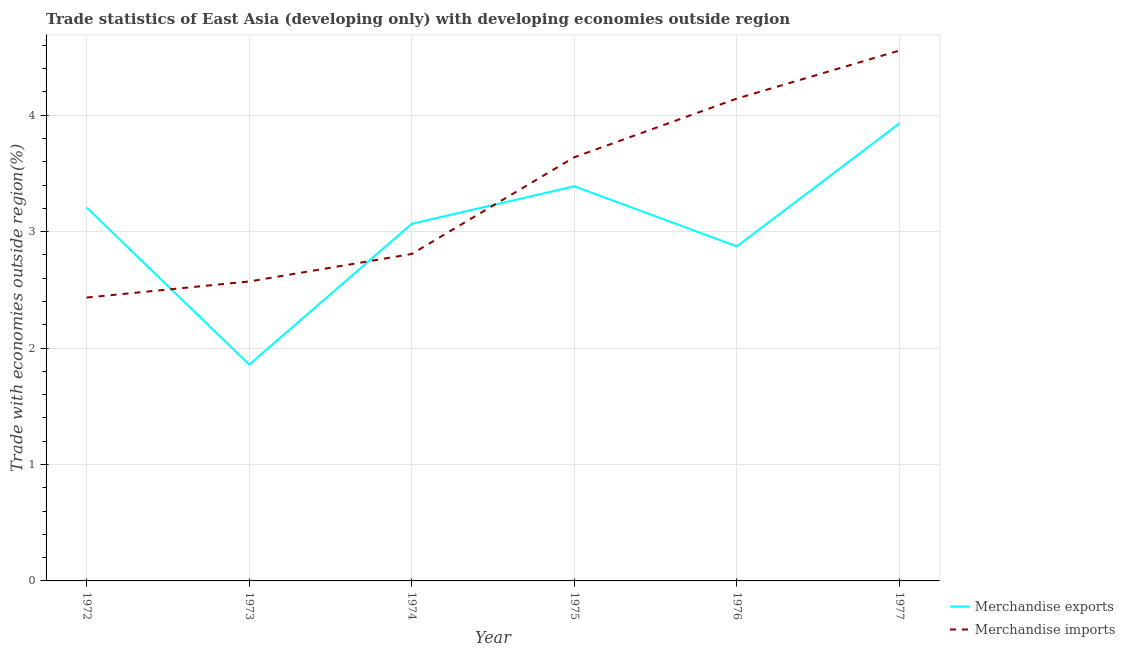How many different coloured lines are there?
Keep it short and to the point. 2. Is the number of lines equal to the number of legend labels?
Your answer should be compact. Yes. What is the merchandise exports in 1976?
Offer a very short reply. 2.87. Across all years, what is the maximum merchandise imports?
Make the answer very short. 4.56. Across all years, what is the minimum merchandise exports?
Your answer should be compact. 1.86. In which year was the merchandise imports maximum?
Offer a terse response. 1977. In which year was the merchandise exports minimum?
Make the answer very short. 1973. What is the total merchandise imports in the graph?
Provide a short and direct response. 20.15. What is the difference between the merchandise imports in 1972 and that in 1977?
Your answer should be very brief. -2.12. What is the difference between the merchandise exports in 1973 and the merchandise imports in 1977?
Your answer should be very brief. -2.7. What is the average merchandise imports per year?
Your answer should be compact. 3.36. In the year 1976, what is the difference between the merchandise imports and merchandise exports?
Make the answer very short. 1.27. In how many years, is the merchandise imports greater than 3.2 %?
Make the answer very short. 3. What is the ratio of the merchandise exports in 1973 to that in 1976?
Make the answer very short. 0.65. Is the merchandise exports in 1973 less than that in 1976?
Provide a short and direct response. Yes. What is the difference between the highest and the second highest merchandise exports?
Provide a short and direct response. 0.54. What is the difference between the highest and the lowest merchandise exports?
Make the answer very short. 2.07. Does the merchandise exports monotonically increase over the years?
Offer a very short reply. No. What is the difference between two consecutive major ticks on the Y-axis?
Keep it short and to the point. 1. Are the values on the major ticks of Y-axis written in scientific E-notation?
Offer a very short reply. No. Does the graph contain any zero values?
Provide a succinct answer. No. Does the graph contain grids?
Ensure brevity in your answer.  Yes. Where does the legend appear in the graph?
Your answer should be compact. Bottom right. What is the title of the graph?
Offer a very short reply. Trade statistics of East Asia (developing only) with developing economies outside region. Does "Net savings(excluding particulate emission damage)" appear as one of the legend labels in the graph?
Offer a very short reply. No. What is the label or title of the Y-axis?
Ensure brevity in your answer.  Trade with economies outside region(%). What is the Trade with economies outside region(%) in Merchandise exports in 1972?
Ensure brevity in your answer.  3.21. What is the Trade with economies outside region(%) in Merchandise imports in 1972?
Provide a succinct answer. 2.43. What is the Trade with economies outside region(%) of Merchandise exports in 1973?
Provide a short and direct response. 1.86. What is the Trade with economies outside region(%) in Merchandise imports in 1973?
Offer a very short reply. 2.57. What is the Trade with economies outside region(%) of Merchandise exports in 1974?
Make the answer very short. 3.07. What is the Trade with economies outside region(%) of Merchandise imports in 1974?
Provide a succinct answer. 2.81. What is the Trade with economies outside region(%) in Merchandise exports in 1975?
Your response must be concise. 3.39. What is the Trade with economies outside region(%) of Merchandise imports in 1975?
Offer a very short reply. 3.64. What is the Trade with economies outside region(%) of Merchandise exports in 1976?
Offer a terse response. 2.87. What is the Trade with economies outside region(%) of Merchandise imports in 1976?
Your answer should be very brief. 4.14. What is the Trade with economies outside region(%) in Merchandise exports in 1977?
Offer a terse response. 3.93. What is the Trade with economies outside region(%) in Merchandise imports in 1977?
Your answer should be compact. 4.56. Across all years, what is the maximum Trade with economies outside region(%) of Merchandise exports?
Your response must be concise. 3.93. Across all years, what is the maximum Trade with economies outside region(%) in Merchandise imports?
Offer a terse response. 4.56. Across all years, what is the minimum Trade with economies outside region(%) of Merchandise exports?
Offer a terse response. 1.86. Across all years, what is the minimum Trade with economies outside region(%) of Merchandise imports?
Your response must be concise. 2.43. What is the total Trade with economies outside region(%) in Merchandise exports in the graph?
Provide a short and direct response. 18.33. What is the total Trade with economies outside region(%) in Merchandise imports in the graph?
Offer a very short reply. 20.15. What is the difference between the Trade with economies outside region(%) in Merchandise exports in 1972 and that in 1973?
Provide a succinct answer. 1.35. What is the difference between the Trade with economies outside region(%) in Merchandise imports in 1972 and that in 1973?
Provide a short and direct response. -0.14. What is the difference between the Trade with economies outside region(%) of Merchandise exports in 1972 and that in 1974?
Your answer should be very brief. 0.14. What is the difference between the Trade with economies outside region(%) of Merchandise imports in 1972 and that in 1974?
Ensure brevity in your answer.  -0.37. What is the difference between the Trade with economies outside region(%) in Merchandise exports in 1972 and that in 1975?
Offer a terse response. -0.18. What is the difference between the Trade with economies outside region(%) in Merchandise imports in 1972 and that in 1975?
Make the answer very short. -1.21. What is the difference between the Trade with economies outside region(%) in Merchandise exports in 1972 and that in 1976?
Provide a short and direct response. 0.33. What is the difference between the Trade with economies outside region(%) in Merchandise imports in 1972 and that in 1976?
Your answer should be very brief. -1.71. What is the difference between the Trade with economies outside region(%) of Merchandise exports in 1972 and that in 1977?
Your answer should be very brief. -0.72. What is the difference between the Trade with economies outside region(%) in Merchandise imports in 1972 and that in 1977?
Your answer should be very brief. -2.12. What is the difference between the Trade with economies outside region(%) of Merchandise exports in 1973 and that in 1974?
Make the answer very short. -1.21. What is the difference between the Trade with economies outside region(%) in Merchandise imports in 1973 and that in 1974?
Give a very brief answer. -0.24. What is the difference between the Trade with economies outside region(%) of Merchandise exports in 1973 and that in 1975?
Your answer should be compact. -1.53. What is the difference between the Trade with economies outside region(%) of Merchandise imports in 1973 and that in 1975?
Offer a terse response. -1.07. What is the difference between the Trade with economies outside region(%) in Merchandise exports in 1973 and that in 1976?
Give a very brief answer. -1.02. What is the difference between the Trade with economies outside region(%) of Merchandise imports in 1973 and that in 1976?
Your answer should be very brief. -1.57. What is the difference between the Trade with economies outside region(%) of Merchandise exports in 1973 and that in 1977?
Provide a succinct answer. -2.07. What is the difference between the Trade with economies outside region(%) in Merchandise imports in 1973 and that in 1977?
Ensure brevity in your answer.  -1.98. What is the difference between the Trade with economies outside region(%) of Merchandise exports in 1974 and that in 1975?
Keep it short and to the point. -0.32. What is the difference between the Trade with economies outside region(%) in Merchandise imports in 1974 and that in 1975?
Give a very brief answer. -0.83. What is the difference between the Trade with economies outside region(%) in Merchandise exports in 1974 and that in 1976?
Provide a short and direct response. 0.19. What is the difference between the Trade with economies outside region(%) in Merchandise imports in 1974 and that in 1976?
Provide a short and direct response. -1.33. What is the difference between the Trade with economies outside region(%) in Merchandise exports in 1974 and that in 1977?
Offer a terse response. -0.86. What is the difference between the Trade with economies outside region(%) in Merchandise imports in 1974 and that in 1977?
Ensure brevity in your answer.  -1.75. What is the difference between the Trade with economies outside region(%) of Merchandise exports in 1975 and that in 1976?
Ensure brevity in your answer.  0.52. What is the difference between the Trade with economies outside region(%) in Merchandise imports in 1975 and that in 1976?
Provide a short and direct response. -0.5. What is the difference between the Trade with economies outside region(%) in Merchandise exports in 1975 and that in 1977?
Offer a very short reply. -0.54. What is the difference between the Trade with economies outside region(%) in Merchandise imports in 1975 and that in 1977?
Give a very brief answer. -0.92. What is the difference between the Trade with economies outside region(%) in Merchandise exports in 1976 and that in 1977?
Make the answer very short. -1.06. What is the difference between the Trade with economies outside region(%) in Merchandise imports in 1976 and that in 1977?
Ensure brevity in your answer.  -0.41. What is the difference between the Trade with economies outside region(%) in Merchandise exports in 1972 and the Trade with economies outside region(%) in Merchandise imports in 1973?
Give a very brief answer. 0.63. What is the difference between the Trade with economies outside region(%) in Merchandise exports in 1972 and the Trade with economies outside region(%) in Merchandise imports in 1974?
Your answer should be very brief. 0.4. What is the difference between the Trade with economies outside region(%) in Merchandise exports in 1972 and the Trade with economies outside region(%) in Merchandise imports in 1975?
Ensure brevity in your answer.  -0.43. What is the difference between the Trade with economies outside region(%) in Merchandise exports in 1972 and the Trade with economies outside region(%) in Merchandise imports in 1976?
Provide a short and direct response. -0.94. What is the difference between the Trade with economies outside region(%) in Merchandise exports in 1972 and the Trade with economies outside region(%) in Merchandise imports in 1977?
Provide a succinct answer. -1.35. What is the difference between the Trade with economies outside region(%) in Merchandise exports in 1973 and the Trade with economies outside region(%) in Merchandise imports in 1974?
Your answer should be compact. -0.95. What is the difference between the Trade with economies outside region(%) in Merchandise exports in 1973 and the Trade with economies outside region(%) in Merchandise imports in 1975?
Your answer should be compact. -1.78. What is the difference between the Trade with economies outside region(%) of Merchandise exports in 1973 and the Trade with economies outside region(%) of Merchandise imports in 1976?
Your answer should be compact. -2.29. What is the difference between the Trade with economies outside region(%) of Merchandise exports in 1973 and the Trade with economies outside region(%) of Merchandise imports in 1977?
Offer a very short reply. -2.7. What is the difference between the Trade with economies outside region(%) in Merchandise exports in 1974 and the Trade with economies outside region(%) in Merchandise imports in 1975?
Keep it short and to the point. -0.57. What is the difference between the Trade with economies outside region(%) in Merchandise exports in 1974 and the Trade with economies outside region(%) in Merchandise imports in 1976?
Ensure brevity in your answer.  -1.08. What is the difference between the Trade with economies outside region(%) in Merchandise exports in 1974 and the Trade with economies outside region(%) in Merchandise imports in 1977?
Your response must be concise. -1.49. What is the difference between the Trade with economies outside region(%) in Merchandise exports in 1975 and the Trade with economies outside region(%) in Merchandise imports in 1976?
Offer a very short reply. -0.75. What is the difference between the Trade with economies outside region(%) of Merchandise exports in 1975 and the Trade with economies outside region(%) of Merchandise imports in 1977?
Your answer should be very brief. -1.17. What is the difference between the Trade with economies outside region(%) of Merchandise exports in 1976 and the Trade with economies outside region(%) of Merchandise imports in 1977?
Offer a terse response. -1.68. What is the average Trade with economies outside region(%) of Merchandise exports per year?
Ensure brevity in your answer.  3.05. What is the average Trade with economies outside region(%) in Merchandise imports per year?
Your response must be concise. 3.36. In the year 1972, what is the difference between the Trade with economies outside region(%) of Merchandise exports and Trade with economies outside region(%) of Merchandise imports?
Offer a terse response. 0.77. In the year 1973, what is the difference between the Trade with economies outside region(%) of Merchandise exports and Trade with economies outside region(%) of Merchandise imports?
Provide a succinct answer. -0.71. In the year 1974, what is the difference between the Trade with economies outside region(%) in Merchandise exports and Trade with economies outside region(%) in Merchandise imports?
Your answer should be very brief. 0.26. In the year 1975, what is the difference between the Trade with economies outside region(%) of Merchandise exports and Trade with economies outside region(%) of Merchandise imports?
Give a very brief answer. -0.25. In the year 1976, what is the difference between the Trade with economies outside region(%) in Merchandise exports and Trade with economies outside region(%) in Merchandise imports?
Offer a terse response. -1.27. In the year 1977, what is the difference between the Trade with economies outside region(%) of Merchandise exports and Trade with economies outside region(%) of Merchandise imports?
Ensure brevity in your answer.  -0.63. What is the ratio of the Trade with economies outside region(%) in Merchandise exports in 1972 to that in 1973?
Provide a succinct answer. 1.73. What is the ratio of the Trade with economies outside region(%) of Merchandise imports in 1972 to that in 1973?
Make the answer very short. 0.95. What is the ratio of the Trade with economies outside region(%) in Merchandise exports in 1972 to that in 1974?
Your response must be concise. 1.05. What is the ratio of the Trade with economies outside region(%) of Merchandise imports in 1972 to that in 1974?
Offer a very short reply. 0.87. What is the ratio of the Trade with economies outside region(%) in Merchandise exports in 1972 to that in 1975?
Offer a very short reply. 0.95. What is the ratio of the Trade with economies outside region(%) of Merchandise imports in 1972 to that in 1975?
Provide a succinct answer. 0.67. What is the ratio of the Trade with economies outside region(%) in Merchandise exports in 1972 to that in 1976?
Offer a terse response. 1.12. What is the ratio of the Trade with economies outside region(%) in Merchandise imports in 1972 to that in 1976?
Provide a short and direct response. 0.59. What is the ratio of the Trade with economies outside region(%) of Merchandise exports in 1972 to that in 1977?
Your response must be concise. 0.82. What is the ratio of the Trade with economies outside region(%) in Merchandise imports in 1972 to that in 1977?
Ensure brevity in your answer.  0.53. What is the ratio of the Trade with economies outside region(%) of Merchandise exports in 1973 to that in 1974?
Your answer should be compact. 0.61. What is the ratio of the Trade with economies outside region(%) of Merchandise imports in 1973 to that in 1974?
Provide a short and direct response. 0.92. What is the ratio of the Trade with economies outside region(%) of Merchandise exports in 1973 to that in 1975?
Your answer should be compact. 0.55. What is the ratio of the Trade with economies outside region(%) in Merchandise imports in 1973 to that in 1975?
Your answer should be compact. 0.71. What is the ratio of the Trade with economies outside region(%) in Merchandise exports in 1973 to that in 1976?
Ensure brevity in your answer.  0.65. What is the ratio of the Trade with economies outside region(%) of Merchandise imports in 1973 to that in 1976?
Keep it short and to the point. 0.62. What is the ratio of the Trade with economies outside region(%) of Merchandise exports in 1973 to that in 1977?
Ensure brevity in your answer.  0.47. What is the ratio of the Trade with economies outside region(%) of Merchandise imports in 1973 to that in 1977?
Keep it short and to the point. 0.56. What is the ratio of the Trade with economies outside region(%) of Merchandise exports in 1974 to that in 1975?
Your response must be concise. 0.9. What is the ratio of the Trade with economies outside region(%) of Merchandise imports in 1974 to that in 1975?
Your answer should be very brief. 0.77. What is the ratio of the Trade with economies outside region(%) of Merchandise exports in 1974 to that in 1976?
Offer a terse response. 1.07. What is the ratio of the Trade with economies outside region(%) in Merchandise imports in 1974 to that in 1976?
Keep it short and to the point. 0.68. What is the ratio of the Trade with economies outside region(%) of Merchandise exports in 1974 to that in 1977?
Give a very brief answer. 0.78. What is the ratio of the Trade with economies outside region(%) of Merchandise imports in 1974 to that in 1977?
Provide a succinct answer. 0.62. What is the ratio of the Trade with economies outside region(%) of Merchandise exports in 1975 to that in 1976?
Provide a succinct answer. 1.18. What is the ratio of the Trade with economies outside region(%) of Merchandise imports in 1975 to that in 1976?
Your answer should be very brief. 0.88. What is the ratio of the Trade with economies outside region(%) of Merchandise exports in 1975 to that in 1977?
Keep it short and to the point. 0.86. What is the ratio of the Trade with economies outside region(%) of Merchandise imports in 1975 to that in 1977?
Give a very brief answer. 0.8. What is the ratio of the Trade with economies outside region(%) in Merchandise exports in 1976 to that in 1977?
Your response must be concise. 0.73. What is the ratio of the Trade with economies outside region(%) of Merchandise imports in 1976 to that in 1977?
Make the answer very short. 0.91. What is the difference between the highest and the second highest Trade with economies outside region(%) in Merchandise exports?
Give a very brief answer. 0.54. What is the difference between the highest and the second highest Trade with economies outside region(%) of Merchandise imports?
Offer a terse response. 0.41. What is the difference between the highest and the lowest Trade with economies outside region(%) of Merchandise exports?
Ensure brevity in your answer.  2.07. What is the difference between the highest and the lowest Trade with economies outside region(%) of Merchandise imports?
Your answer should be very brief. 2.12. 